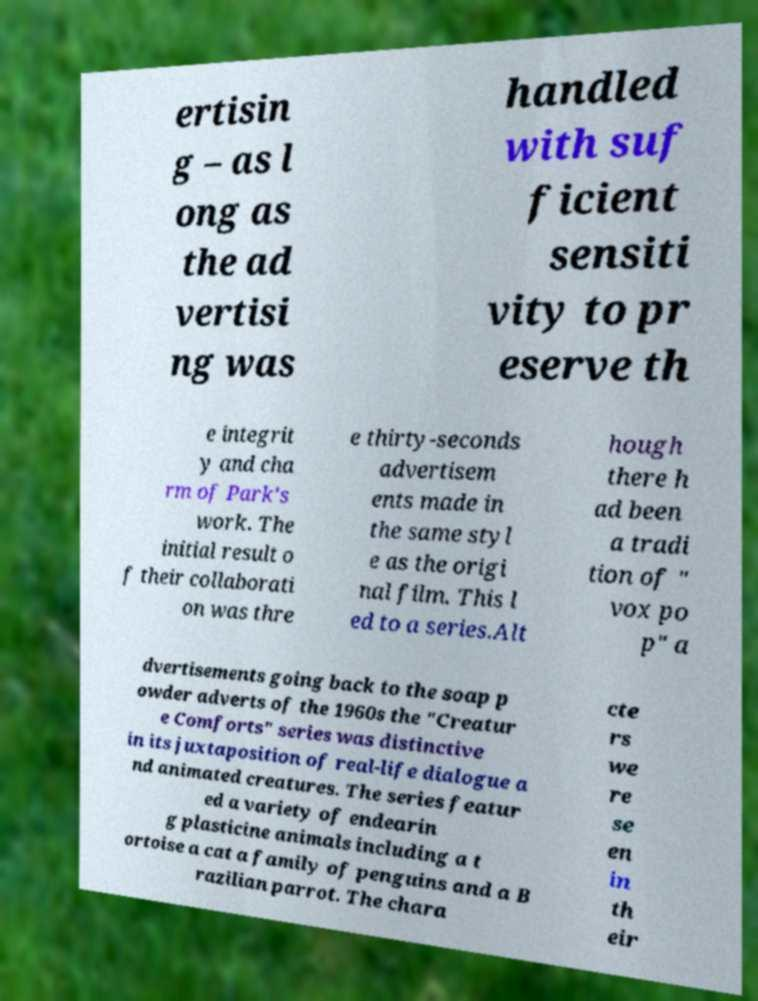Can you accurately transcribe the text from the provided image for me? ertisin g – as l ong as the ad vertisi ng was handled with suf ficient sensiti vity to pr eserve th e integrit y and cha rm of Park's work. The initial result o f their collaborati on was thre e thirty-seconds advertisem ents made in the same styl e as the origi nal film. This l ed to a series.Alt hough there h ad been a tradi tion of " vox po p" a dvertisements going back to the soap p owder adverts of the 1960s the "Creatur e Comforts" series was distinctive in its juxtaposition of real-life dialogue a nd animated creatures. The series featur ed a variety of endearin g plasticine animals including a t ortoise a cat a family of penguins and a B razilian parrot. The chara cte rs we re se en in th eir 